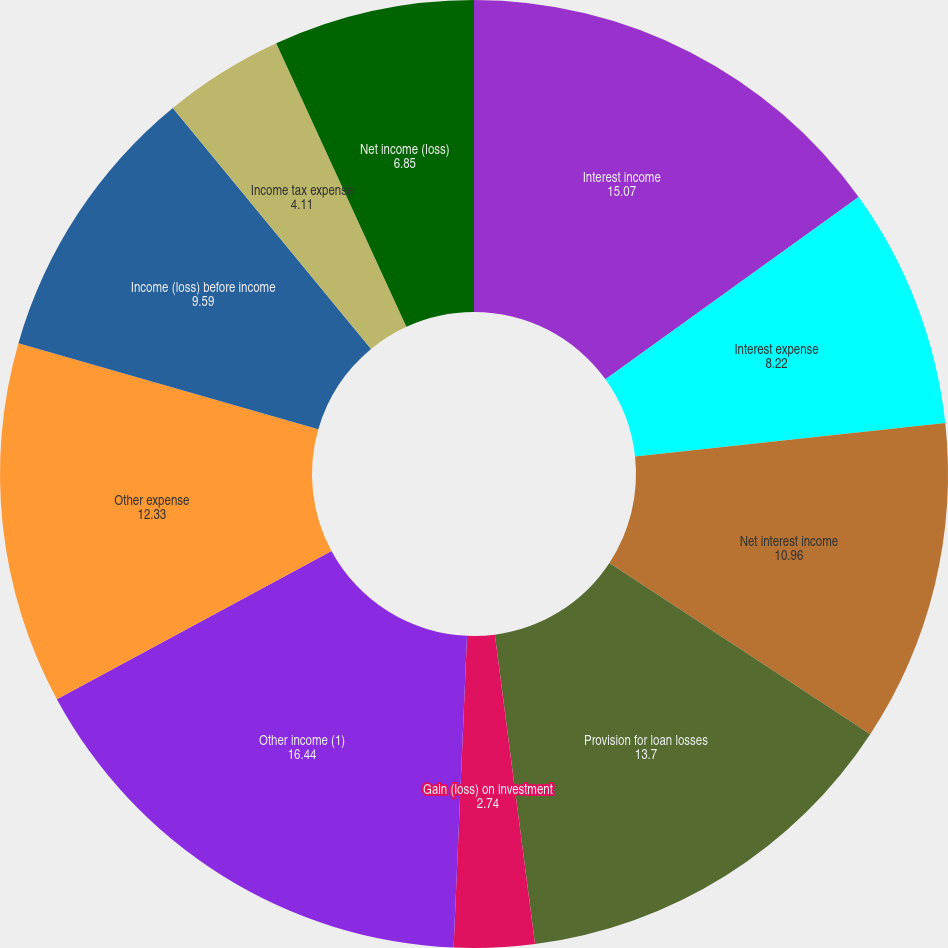Convert chart. <chart><loc_0><loc_0><loc_500><loc_500><pie_chart><fcel>Interest income<fcel>Interest expense<fcel>Net interest income<fcel>Provision for loan losses<fcel>Gain (loss) on investment<fcel>Other income (1)<fcel>Other expense<fcel>Income (loss) before income<fcel>Income tax expense<fcel>Net income (loss)<nl><fcel>15.07%<fcel>8.22%<fcel>10.96%<fcel>13.7%<fcel>2.74%<fcel>16.44%<fcel>12.33%<fcel>9.59%<fcel>4.11%<fcel>6.85%<nl></chart> 